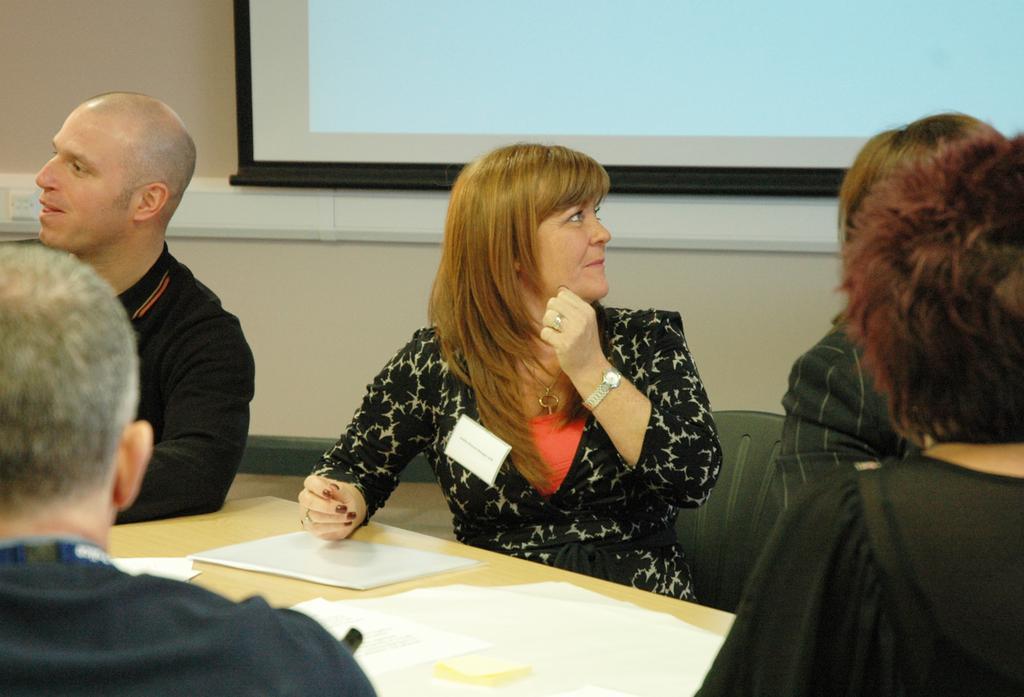Can you describe this image briefly? In this image I can see few people are sitting on chairs. I can also see most of them are wearing black dress. Here I can see a table and on it I can see white colour papers. In background I can see projector screen. 